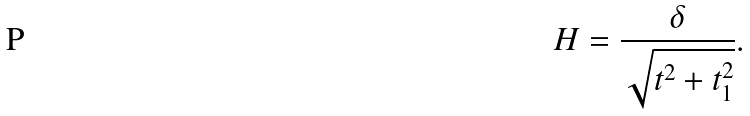Convert formula to latex. <formula><loc_0><loc_0><loc_500><loc_500>H = \frac { \delta } { \sqrt { t ^ { 2 } + t ^ { 2 } _ { 1 } } } .</formula> 